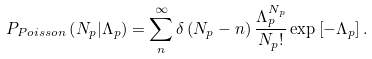<formula> <loc_0><loc_0><loc_500><loc_500>P _ { P o i s s o n } \left ( N _ { p } | \Lambda _ { p } \right ) = \sum _ { n } ^ { \infty } \delta \left ( N _ { p } - n \right ) \frac { \Lambda _ { p } ^ { N _ { p } } } { N _ { p } ! } \exp \left [ - \Lambda _ { p } \right ] .</formula> 